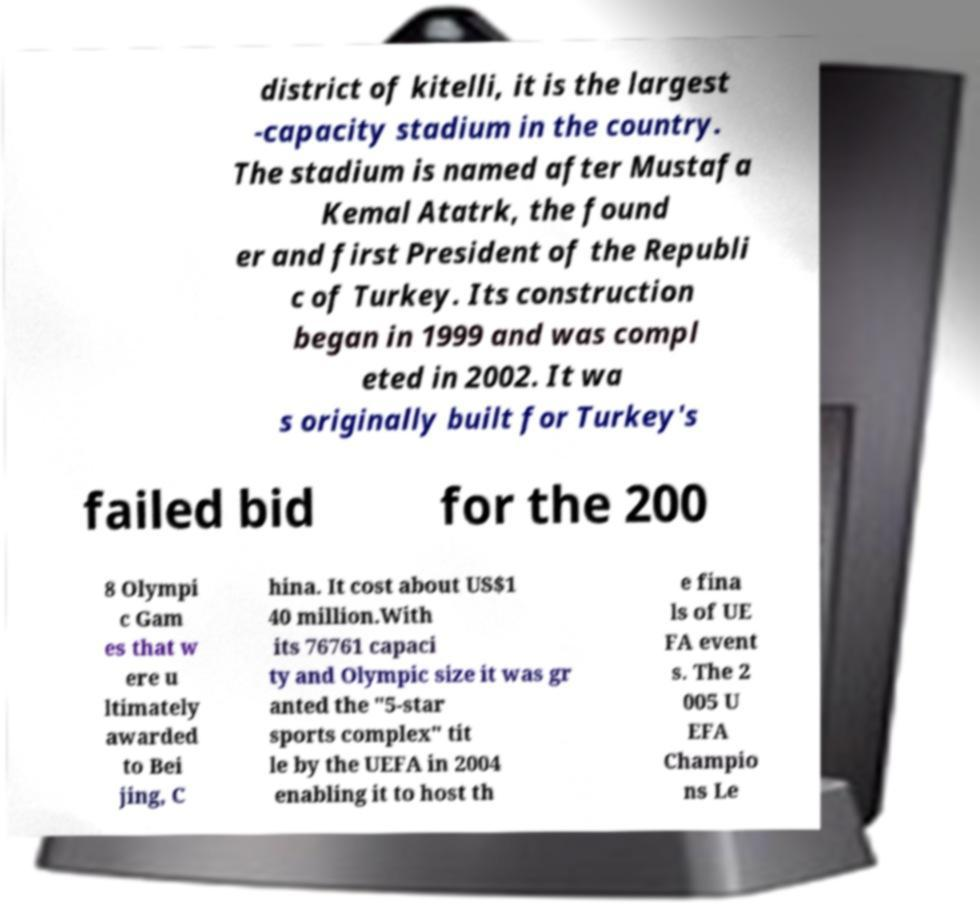Can you accurately transcribe the text from the provided image for me? district of kitelli, it is the largest -capacity stadium in the country. The stadium is named after Mustafa Kemal Atatrk, the found er and first President of the Republi c of Turkey. Its construction began in 1999 and was compl eted in 2002. It wa s originally built for Turkey's failed bid for the 200 8 Olympi c Gam es that w ere u ltimately awarded to Bei jing, C hina. It cost about US$1 40 million.With its 76761 capaci ty and Olympic size it was gr anted the "5-star sports complex" tit le by the UEFA in 2004 enabling it to host th e fina ls of UE FA event s. The 2 005 U EFA Champio ns Le 